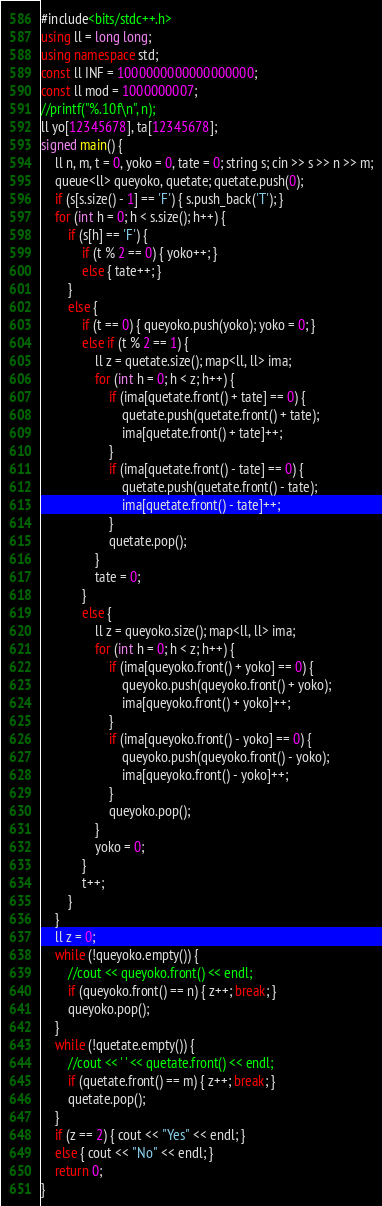Convert code to text. <code><loc_0><loc_0><loc_500><loc_500><_C++_>#include<bits/stdc++.h>
using ll = long long;
using namespace std;
const ll INF = 1000000000000000000;
const ll mod = 1000000007;
//printf("%.10f\n", n);
ll yo[12345678], ta[12345678];
signed main() {
    ll n, m, t = 0, yoko = 0, tate = 0; string s; cin >> s >> n >> m;
    queue<ll> queyoko, quetate; quetate.push(0);
    if (s[s.size() - 1] == 'F') { s.push_back('T'); }
    for (int h = 0; h < s.size(); h++) {
        if (s[h] == 'F') {
            if (t % 2 == 0) { yoko++; }
            else { tate++; }
        }
        else {
            if (t == 0) { queyoko.push(yoko); yoko = 0; }
            else if (t % 2 == 1) {
                ll z = quetate.size(); map<ll, ll> ima;
                for (int h = 0; h < z; h++) {
                    if (ima[quetate.front() + tate] == 0) {
                        quetate.push(quetate.front() + tate);
                        ima[quetate.front() + tate]++;
                    }
                    if (ima[quetate.front() - tate] == 0) {
                        quetate.push(quetate.front() - tate);
                        ima[quetate.front() - tate]++;
                    }
                    quetate.pop();
                }
                tate = 0;
            }
            else {
                ll z = queyoko.size(); map<ll, ll> ima;
                for (int h = 0; h < z; h++) {
                    if (ima[queyoko.front() + yoko] == 0) {
                        queyoko.push(queyoko.front() + yoko);
                        ima[queyoko.front() + yoko]++;
                    }
                    if (ima[queyoko.front() - yoko] == 0) {
                        queyoko.push(queyoko.front() - yoko);
                        ima[queyoko.front() - yoko]++;
                    }
                    queyoko.pop();
                }
                yoko = 0;
            }
            t++;
        }
    }
    ll z = 0;
    while (!queyoko.empty()) {
        //cout << queyoko.front() << endl;
        if (queyoko.front() == n) { z++; break; }
        queyoko.pop();
    }
    while (!quetate.empty()) {
        //cout << ' ' << quetate.front() << endl;
        if (quetate.front() == m) { z++; break; }
        quetate.pop();
    }
    if (z == 2) { cout << "Yes" << endl; }
    else { cout << "No" << endl; }
    return 0;
}</code> 